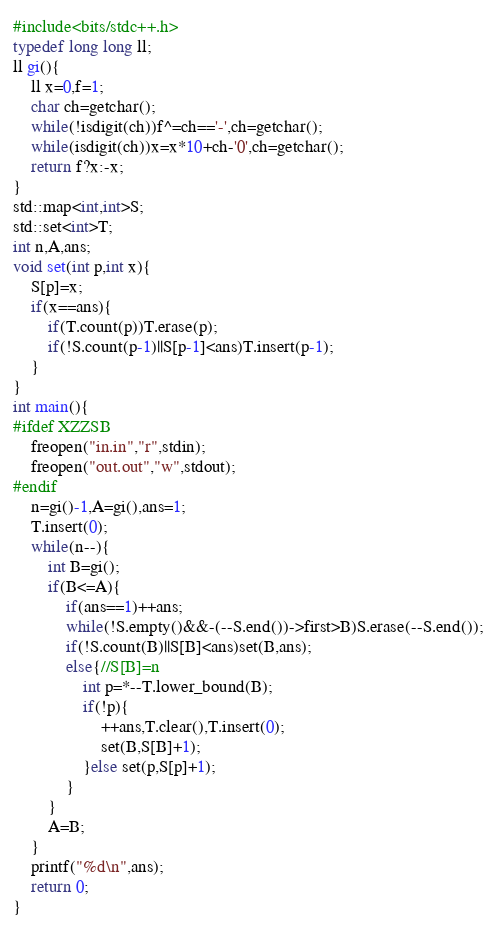Convert code to text. <code><loc_0><loc_0><loc_500><loc_500><_C++_>#include<bits/stdc++.h>
typedef long long ll;
ll gi(){
	ll x=0,f=1;
	char ch=getchar();
	while(!isdigit(ch))f^=ch=='-',ch=getchar();
	while(isdigit(ch))x=x*10+ch-'0',ch=getchar();
	return f?x:-x;
}
std::map<int,int>S;
std::set<int>T;
int n,A,ans;
void set(int p,int x){
	S[p]=x;
	if(x==ans){
		if(T.count(p))T.erase(p);
		if(!S.count(p-1)||S[p-1]<ans)T.insert(p-1);
	}
}
int main(){
#ifdef XZZSB
	freopen("in.in","r",stdin);
	freopen("out.out","w",stdout);
#endif
	n=gi()-1,A=gi(),ans=1;
	T.insert(0);
	while(n--){
		int B=gi();
		if(B<=A){
			if(ans==1)++ans;
			while(!S.empty()&&-(--S.end())->first>B)S.erase(--S.end());
			if(!S.count(B)||S[B]<ans)set(B,ans);
			else{//S[B]=n
				int p=*--T.lower_bound(B);
				if(!p){
					++ans,T.clear(),T.insert(0);
					set(B,S[B]+1);
				}else set(p,S[p]+1);
			}
		}
		A=B;
	}
	printf("%d\n",ans);
	return 0;
}
</code> 